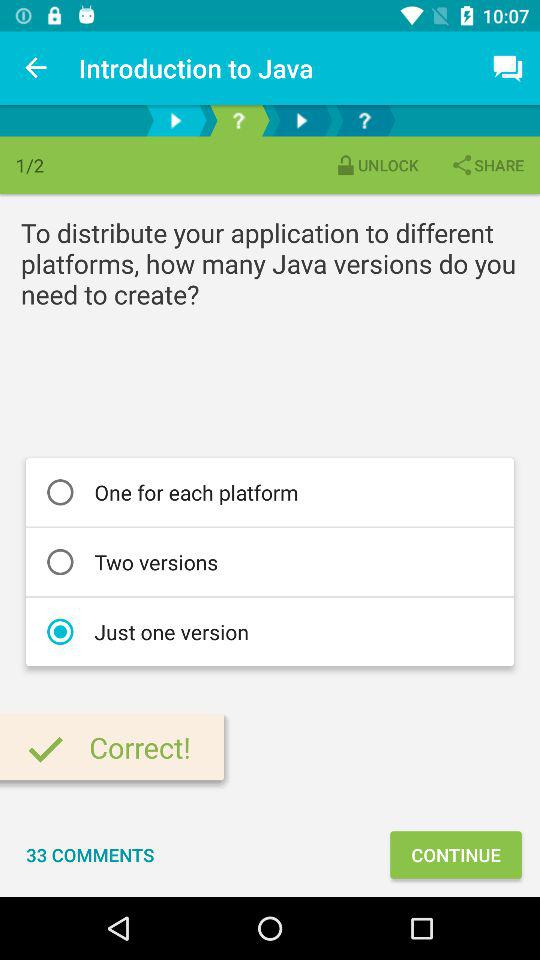What is the total number of comments? The total number of comments is 33. 